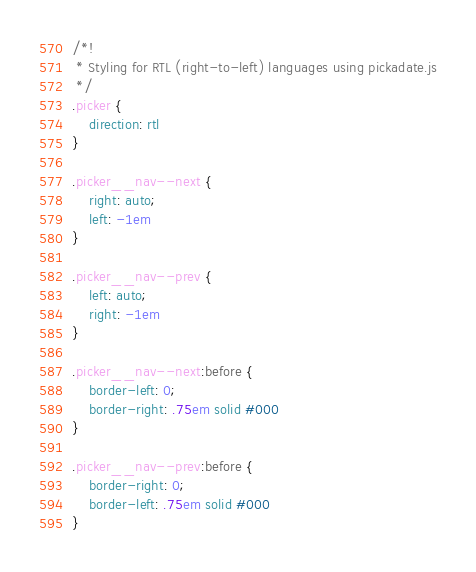<code> <loc_0><loc_0><loc_500><loc_500><_CSS_>/*!
 * Styling for RTL (right-to-left) languages using pickadate.js
 */
.picker {
    direction: rtl
}

.picker__nav--next {
    right: auto;
    left: -1em
}

.picker__nav--prev {
    left: auto;
    right: -1em
}

.picker__nav--next:before {
    border-left: 0;
    border-right: .75em solid #000
}

.picker__nav--prev:before {
    border-right: 0;
    border-left: .75em solid #000
}</code> 